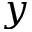<formula> <loc_0><loc_0><loc_500><loc_500>y</formula> 